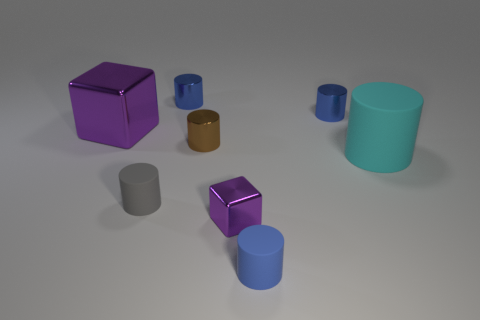Subtract all gray balls. How many blue cylinders are left? 3 Subtract all blue cylinders. How many cylinders are left? 3 Subtract all small rubber cylinders. How many cylinders are left? 4 Subtract 1 cylinders. How many cylinders are left? 5 Add 2 gray rubber cylinders. How many objects exist? 10 Subtract all purple cylinders. Subtract all brown cubes. How many cylinders are left? 6 Subtract all blocks. How many objects are left? 6 Subtract 0 red cylinders. How many objects are left? 8 Subtract all metallic things. Subtract all big cubes. How many objects are left? 2 Add 1 purple shiny objects. How many purple shiny objects are left? 3 